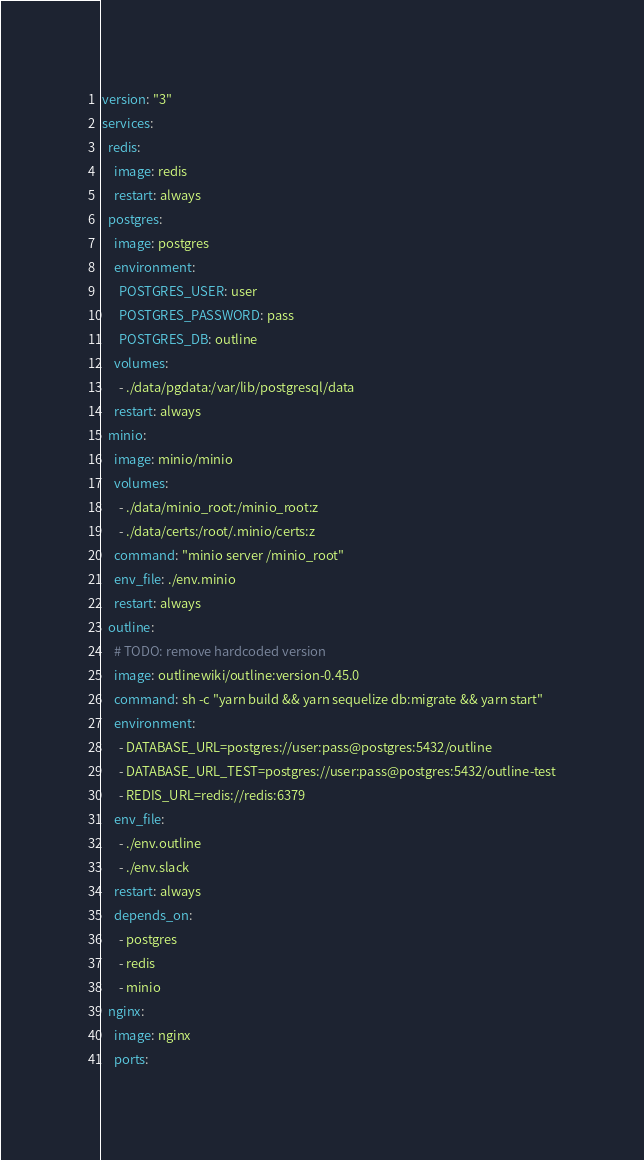<code> <loc_0><loc_0><loc_500><loc_500><_YAML_>version: "3"
services:
  redis:
    image: redis
    restart: always
  postgres:
    image: postgres
    environment:
      POSTGRES_USER: user
      POSTGRES_PASSWORD: pass
      POSTGRES_DB: outline
    volumes:
      - ./data/pgdata:/var/lib/postgresql/data
    restart: always
  minio:
    image: minio/minio
    volumes:
      - ./data/minio_root:/minio_root:z
      - ./data/certs:/root/.minio/certs:z
    command: "minio server /minio_root"
    env_file: ./env.minio
    restart: always
  outline:
    # TODO: remove hardcoded version
    image: outlinewiki/outline:version-0.45.0
    command: sh -c "yarn build && yarn sequelize db:migrate && yarn start"
    environment:
      - DATABASE_URL=postgres://user:pass@postgres:5432/outline
      - DATABASE_URL_TEST=postgres://user:pass@postgres:5432/outline-test
      - REDIS_URL=redis://redis:6379
    env_file:
      - ./env.outline
      - ./env.slack
    restart: always
    depends_on:
      - postgres
      - redis
      - minio
  nginx:
    image: nginx
    ports:</code> 